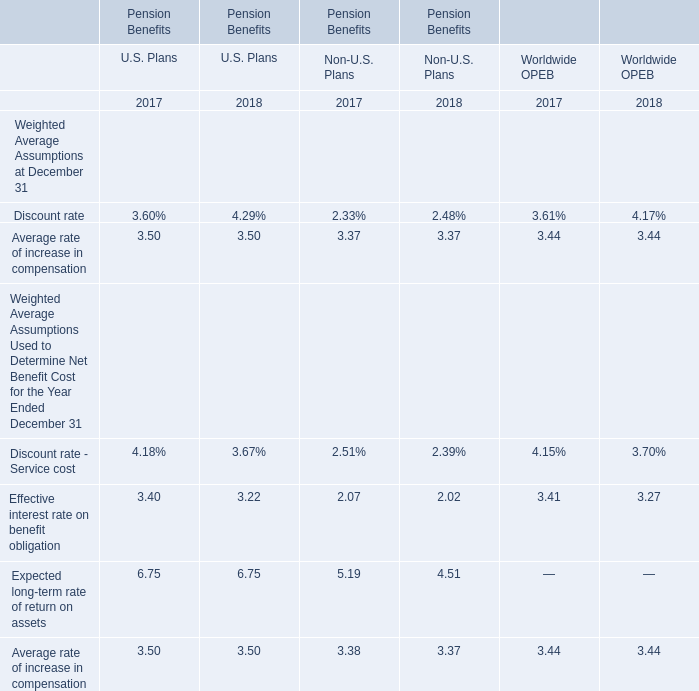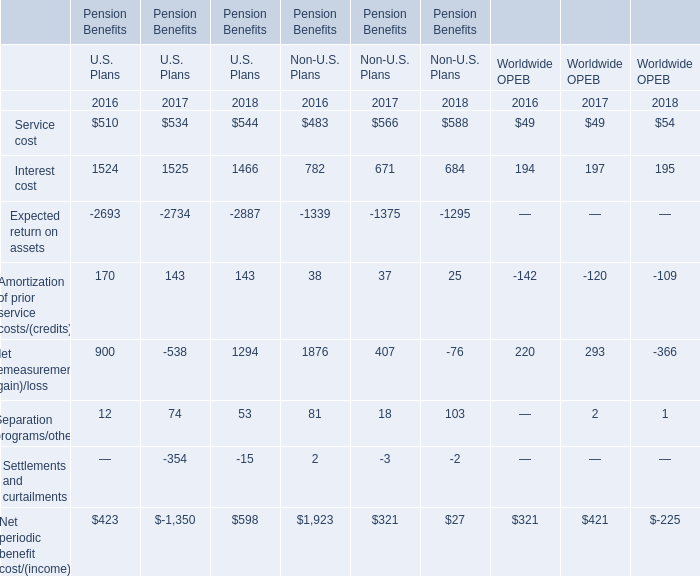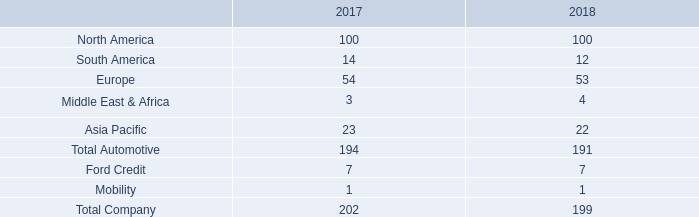What's the total value of all U.S. Plans that are in the range of 0 and 200 in 2016 for Pension Benefits? 
Computations: (170 + 12)
Answer: 182.0. 